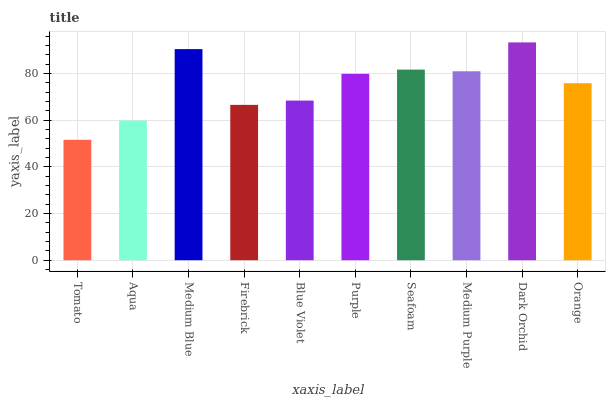Is Tomato the minimum?
Answer yes or no. Yes. Is Dark Orchid the maximum?
Answer yes or no. Yes. Is Aqua the minimum?
Answer yes or no. No. Is Aqua the maximum?
Answer yes or no. No. Is Aqua greater than Tomato?
Answer yes or no. Yes. Is Tomato less than Aqua?
Answer yes or no. Yes. Is Tomato greater than Aqua?
Answer yes or no. No. Is Aqua less than Tomato?
Answer yes or no. No. Is Purple the high median?
Answer yes or no. Yes. Is Orange the low median?
Answer yes or no. Yes. Is Orange the high median?
Answer yes or no. No. Is Seafoam the low median?
Answer yes or no. No. 